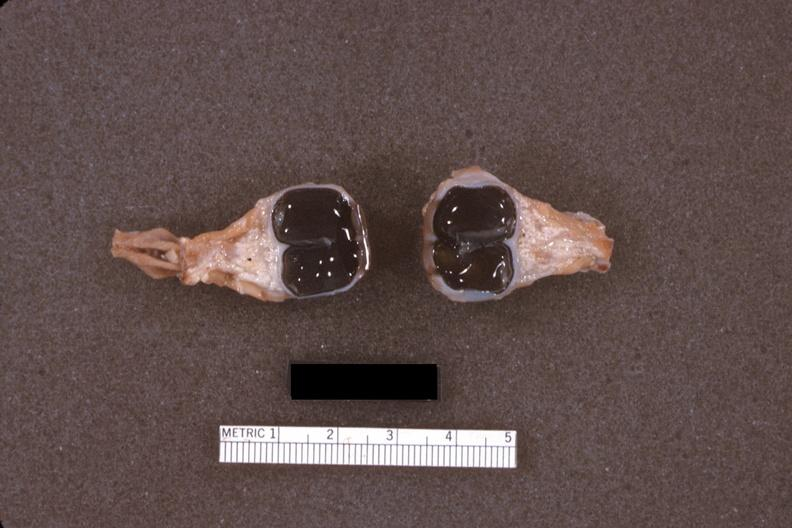what does this image show?
Answer the question using a single word or phrase. Fixed tissue dissected eyes 